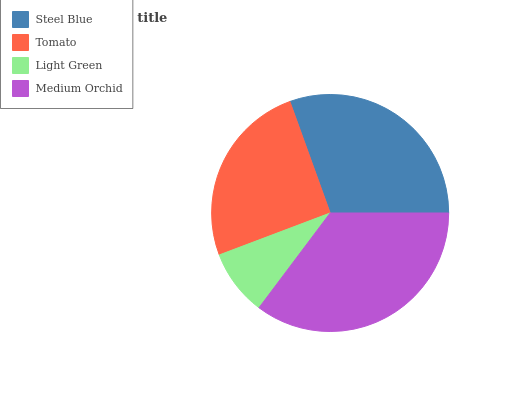Is Light Green the minimum?
Answer yes or no. Yes. Is Medium Orchid the maximum?
Answer yes or no. Yes. Is Tomato the minimum?
Answer yes or no. No. Is Tomato the maximum?
Answer yes or no. No. Is Steel Blue greater than Tomato?
Answer yes or no. Yes. Is Tomato less than Steel Blue?
Answer yes or no. Yes. Is Tomato greater than Steel Blue?
Answer yes or no. No. Is Steel Blue less than Tomato?
Answer yes or no. No. Is Steel Blue the high median?
Answer yes or no. Yes. Is Tomato the low median?
Answer yes or no. Yes. Is Light Green the high median?
Answer yes or no. No. Is Medium Orchid the low median?
Answer yes or no. No. 